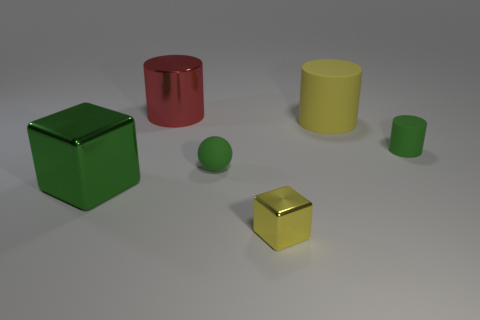The tiny yellow thing is what shape?
Provide a short and direct response. Cube. Is the size of the shiny block that is behind the yellow shiny block the same as the yellow metal block?
Give a very brief answer. No. Are there any small cylinders made of the same material as the green sphere?
Provide a succinct answer. Yes. How many objects are small matte objects behind the small green matte ball or blue cylinders?
Offer a terse response. 1. Are any yellow metallic balls visible?
Provide a short and direct response. No. There is a object that is both to the right of the yellow shiny object and in front of the large yellow matte cylinder; what is its shape?
Your answer should be very brief. Cylinder. There is a block that is behind the small shiny block; what is its size?
Provide a succinct answer. Large. Is the color of the metal cube behind the small yellow thing the same as the tiny ball?
Give a very brief answer. Yes. What number of other big things are the same shape as the yellow shiny thing?
Make the answer very short. 1. How many objects are large cylinders right of the rubber ball or yellow things to the right of the yellow metallic block?
Provide a succinct answer. 1. 